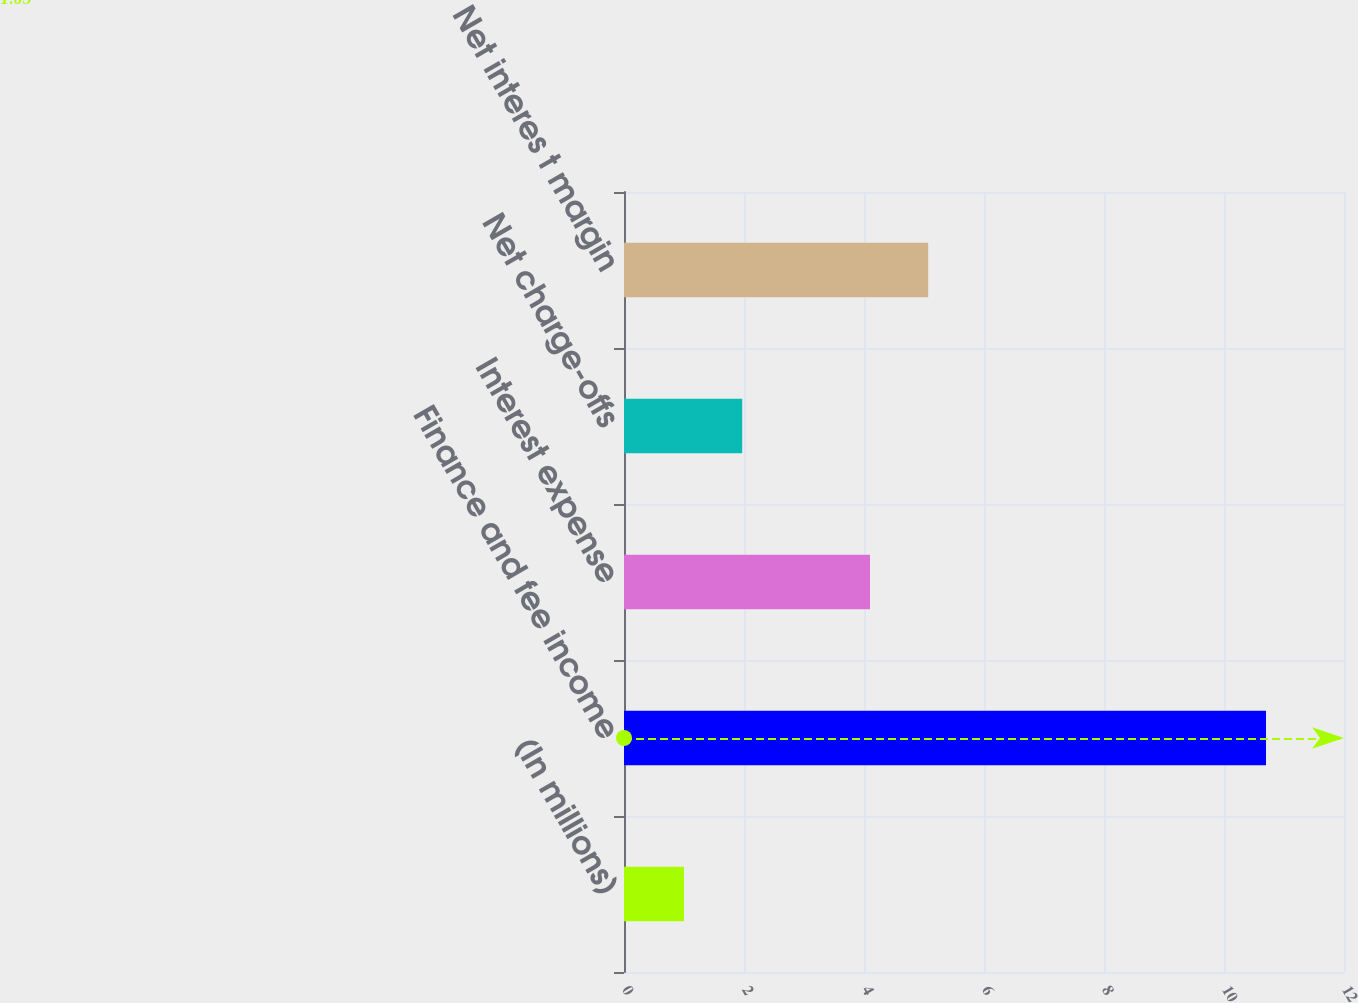Convert chart. <chart><loc_0><loc_0><loc_500><loc_500><bar_chart><fcel>(In millions)<fcel>Finance and fee income<fcel>Interest expense<fcel>Net charge-offs<fcel>Net interes t margin<nl><fcel>1<fcel>10.7<fcel>4.1<fcel>1.97<fcel>5.07<nl></chart> 